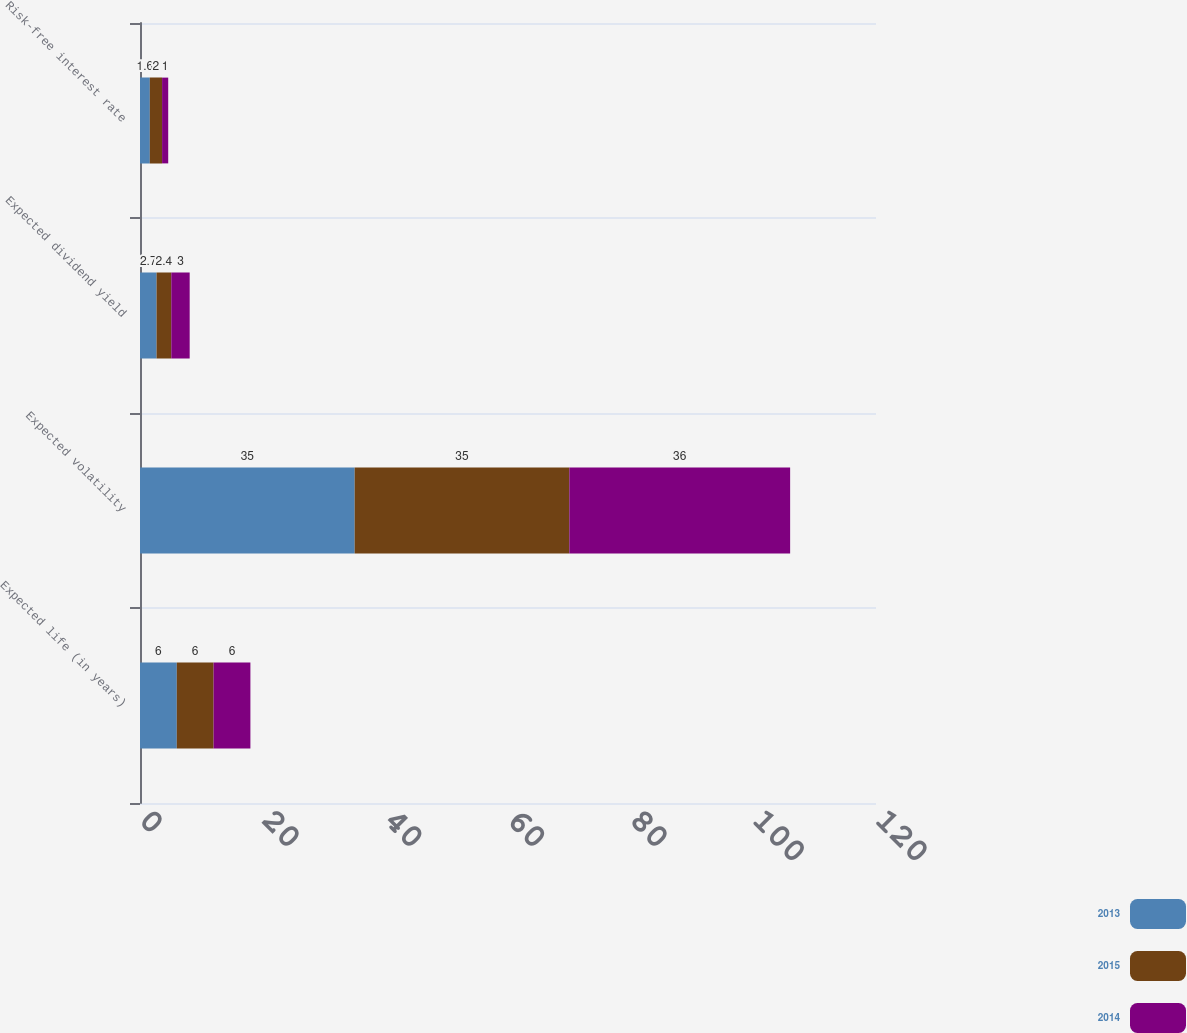<chart> <loc_0><loc_0><loc_500><loc_500><stacked_bar_chart><ecel><fcel>Expected life (in years)<fcel>Expected volatility<fcel>Expected dividend yield<fcel>Risk-free interest rate<nl><fcel>2013<fcel>6<fcel>35<fcel>2.7<fcel>1.6<nl><fcel>2015<fcel>6<fcel>35<fcel>2.4<fcel>2<nl><fcel>2014<fcel>6<fcel>36<fcel>3<fcel>1<nl></chart> 